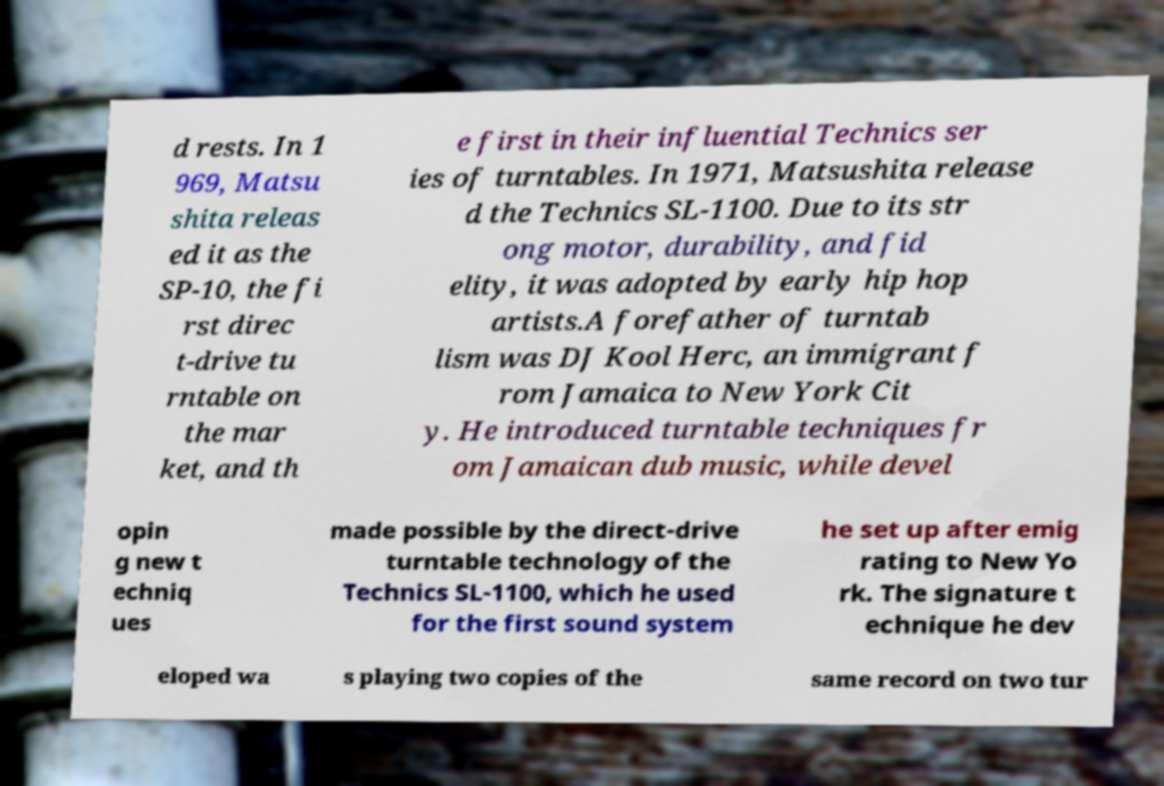There's text embedded in this image that I need extracted. Can you transcribe it verbatim? d rests. In 1 969, Matsu shita releas ed it as the SP-10, the fi rst direc t-drive tu rntable on the mar ket, and th e first in their influential Technics ser ies of turntables. In 1971, Matsushita release d the Technics SL-1100. Due to its str ong motor, durability, and fid elity, it was adopted by early hip hop artists.A forefather of turntab lism was DJ Kool Herc, an immigrant f rom Jamaica to New York Cit y. He introduced turntable techniques fr om Jamaican dub music, while devel opin g new t echniq ues made possible by the direct-drive turntable technology of the Technics SL-1100, which he used for the first sound system he set up after emig rating to New Yo rk. The signature t echnique he dev eloped wa s playing two copies of the same record on two tur 